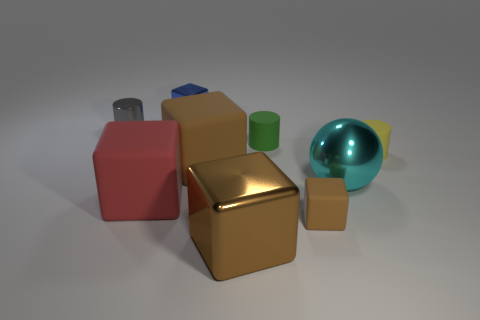How would you interpret the arrangement of these objects? The arrangement of these objects looks intentional, as if they were carefully placed for a still life composition. It might be meant to demonstrate contrasts—in shape, color, and texture—or could be an exercise in 3D rendering. The varied sizes and colors draw the eye across the scene, creating a balanced yet dynamic visual interest. 